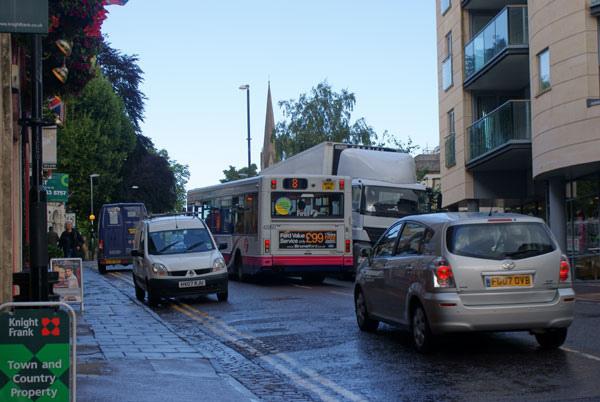How many cars are on the street?
Concise answer only. 2. Why has traffic stopped?
Give a very brief answer. Congestion. What way can this road be entered?
Answer briefly. Can't tell. What color is the bus?
Write a very short answer. White. Are this vehicle's tail lights on?
Give a very brief answer. Yes. Where is the street located in?
Short answer required. Europe. What kind of property is advertised to the left?
Keep it brief. Town and country. How many cars are there?
Concise answer only. 5. Are there clouds in the sky?
Write a very short answer. No. Is this a one or two way street?
Give a very brief answer. 2 way. What kind of vehicles are these?
Write a very short answer. Cars. What color is illuminated on the traffic lights?
Concise answer only. Yellow. Who drives the two white cars next to the bus?
Give a very brief answer. People. Is there a one way street?
Keep it brief. No. Is this a double decker bus?
Keep it brief. No. Which vehicle is newest?
Write a very short answer. Suv. 